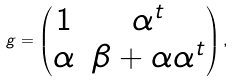Convert formula to latex. <formula><loc_0><loc_0><loc_500><loc_500>g = \begin{pmatrix} 1 & \alpha ^ { t } \\ \alpha & \beta + \alpha \alpha ^ { t } \end{pmatrix} ,</formula> 